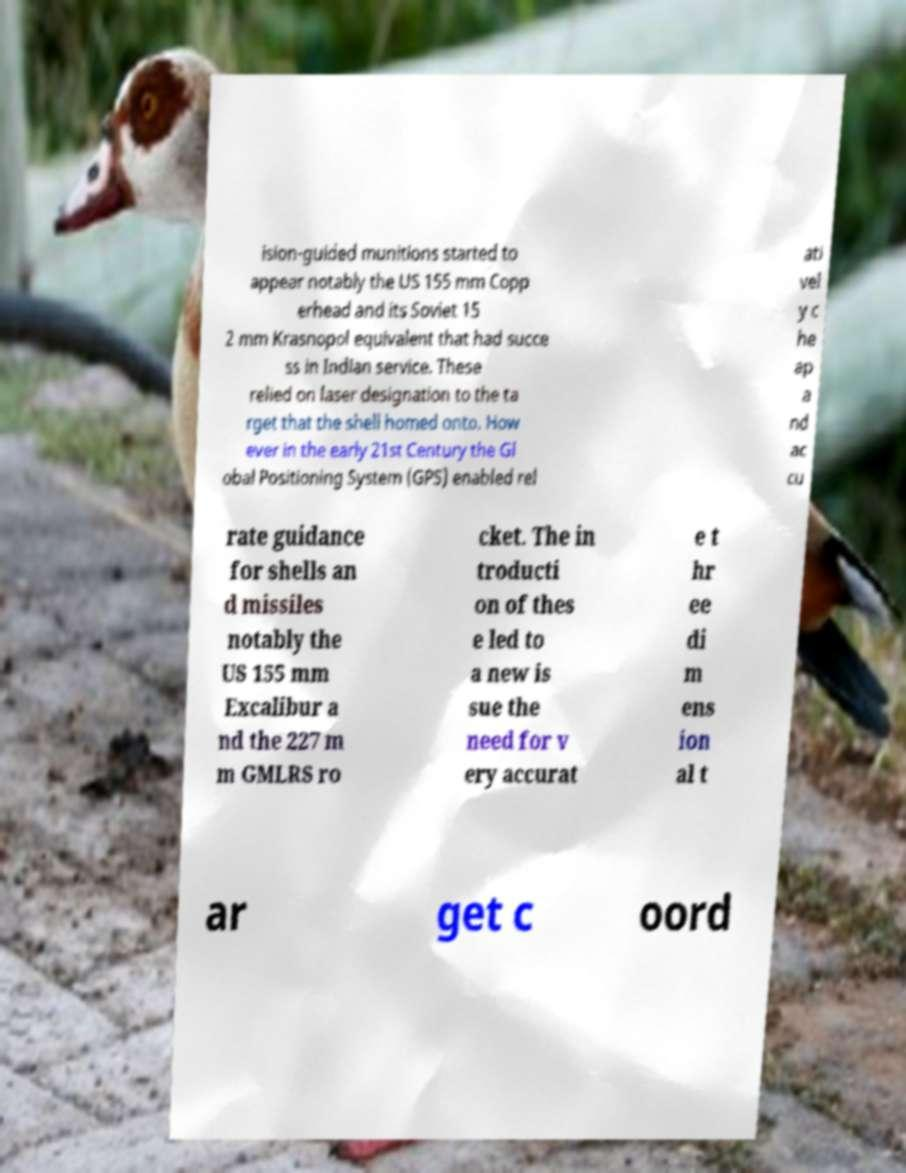I need the written content from this picture converted into text. Can you do that? ision-guided munitions started to appear notably the US 155 mm Copp erhead and its Soviet 15 2 mm Krasnopol equivalent that had succe ss in Indian service. These relied on laser designation to the ta rget that the shell homed onto. How ever in the early 21st Century the Gl obal Positioning System (GPS) enabled rel ati vel y c he ap a nd ac cu rate guidance for shells an d missiles notably the US 155 mm Excalibur a nd the 227 m m GMLRS ro cket. The in troducti on of thes e led to a new is sue the need for v ery accurat e t hr ee di m ens ion al t ar get c oord 